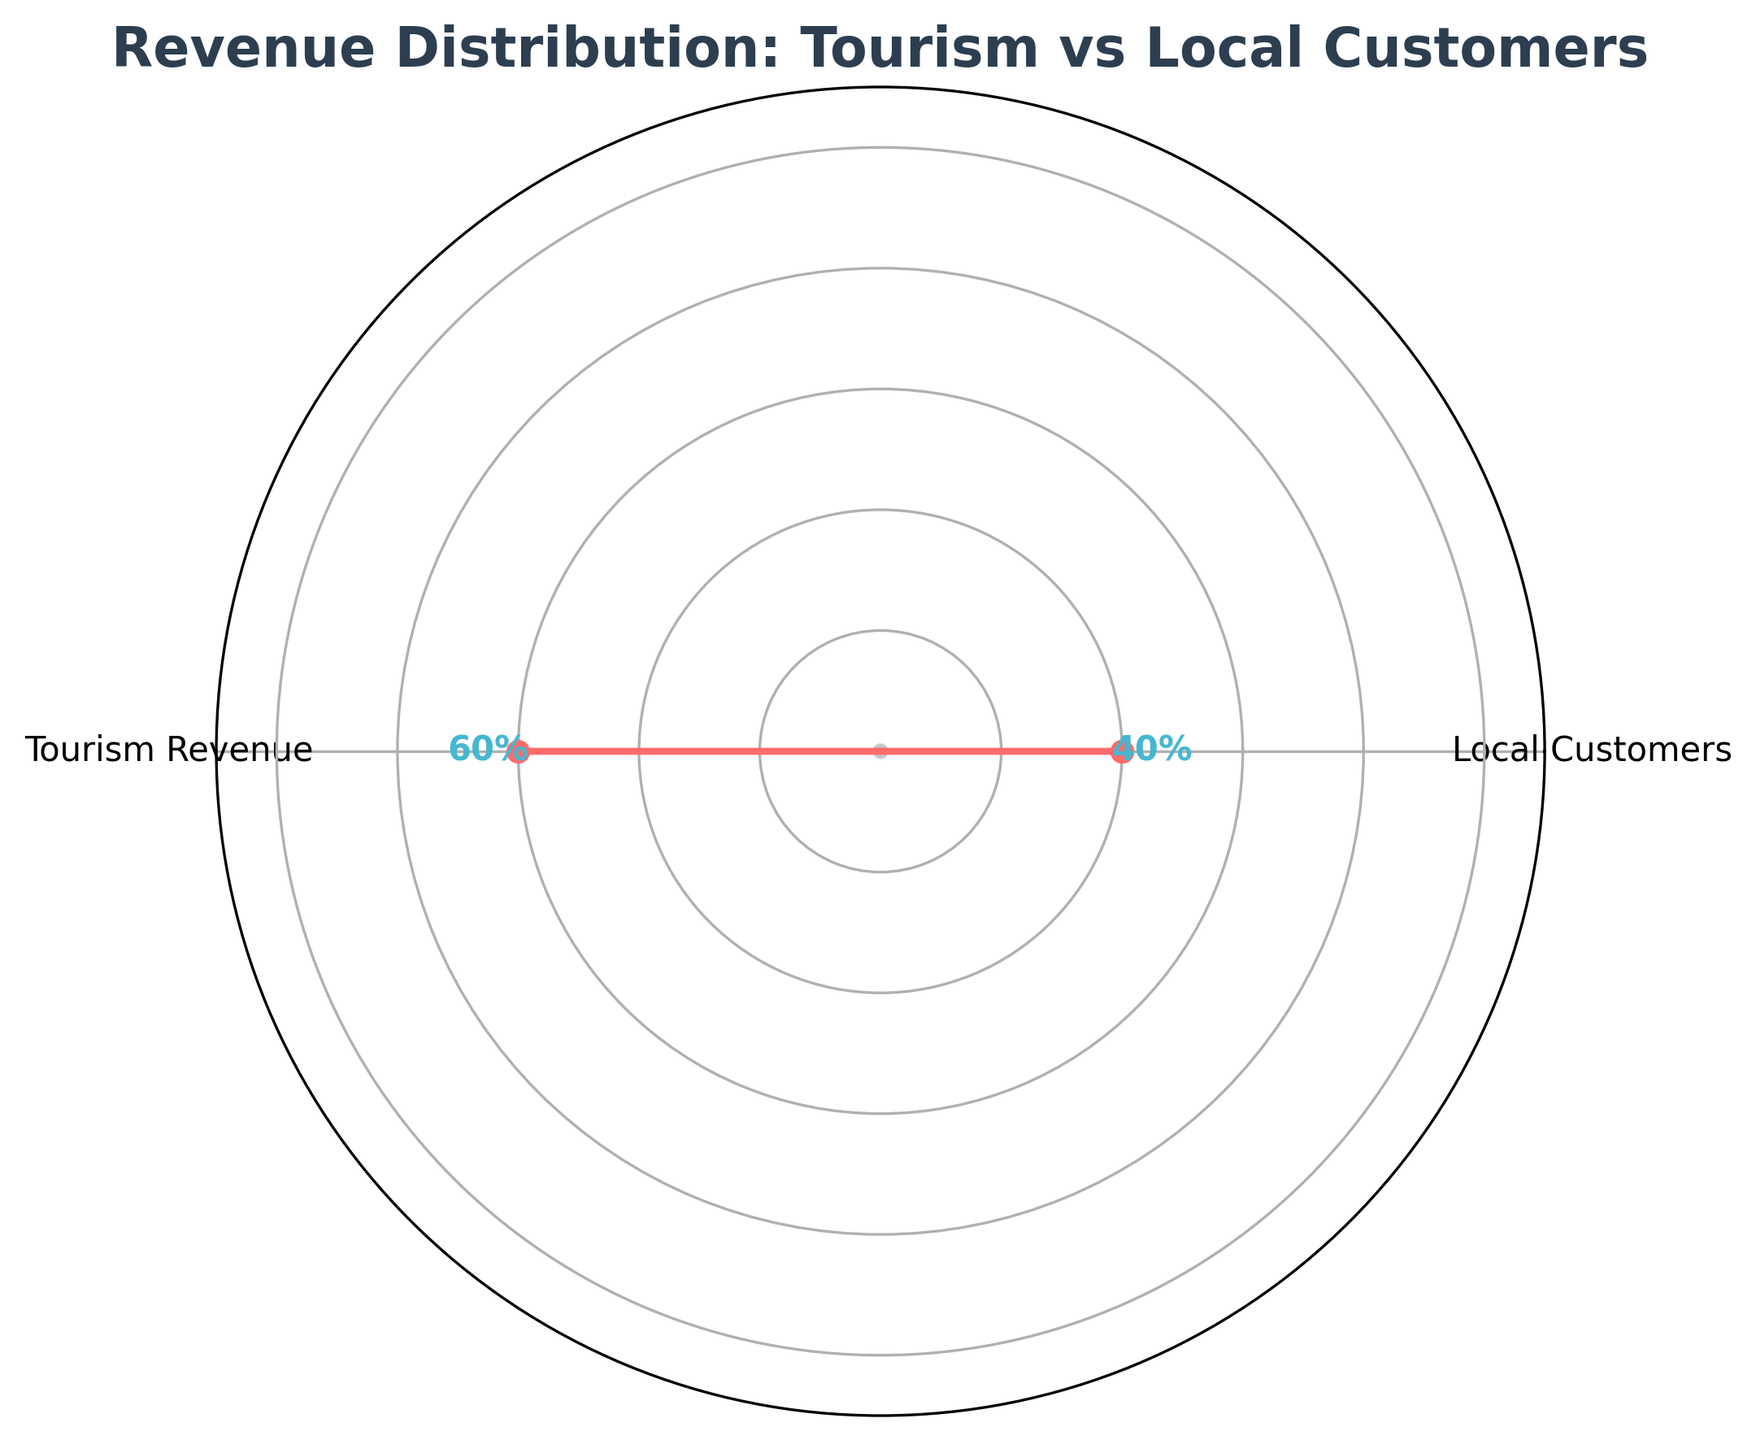What is the title of the plot? The title of the plot is usually located at the top center of the figure. In this case, it reads "Revenue Distribution: Tourism vs Local Customers".
Answer: Revenue Distribution: Tourism vs Local Customers What percentage of the revenue is from local customers? The radial chart labels indicate the percentage. For local customers, the indicated value is 40%.
Answer: 40% Which category contributes more to the revenue, local customers or tourism? By comparing the two values (40% for local customers and 60% for tourism revenue), tourism contributes more.
Answer: Tourism How much higher is the tourism revenue compared to local customer revenue? The tourism revenue is 60%, and local customer revenue is 40%. The difference is calculated as 60% - 40% = 20%.
Answer: 20% Is the sum of local customer and tourism revenue exceeding 100%? The two values provided are 40% and 60%, adding them together results in 40% + 60% = 100%. Therefore, they exactly total 100% and do not exceed it.
Answer: No, it totals 100% What color distinguishes the values on the gauge chart? Upon observing the filled areas of the plot, the colors used can be seen as distinct. The plot uses shades of teal (#4ECDC4) for the filling and shades of coral (#FF6B6B) for the outline.
Answer: Teal and Coral What is the range marked on the chart’s radial axis? By inspecting the radial axis, we see it is marked up to 110%, though no value exceeds 100%.
Answer: 0% to 110% How many categories are represented in this gauge chart? By reviewing the labels on the radial plot, we can see two distinct categories are presented: "Local Customers" and "Tourism Revenue".
Answer: Two Does the chart include value labels for each category? Each segment of the gauge has a corresponding value label, indicating 40% for Local Customers and 60% for Tourism Revenue.
Answer: Yes How are the category values visually emphasized in the plot? The values are depicted as points on the radial plot, using circular markers and different colors for the filling and outline. Additionally, text labels next to the points specify the percentages.
Answer: With value points, colors, and text labels 